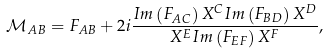<formula> <loc_0><loc_0><loc_500><loc_500>\mathcal { M } _ { A B } = F _ { A B } + 2 i \frac { I m \left ( F _ { A C } \right ) X ^ { C } I m \left ( F _ { B D } \right ) X ^ { D } } { X ^ { E } I m \left ( F _ { E F } \right ) X ^ { F } } ,</formula> 